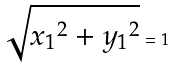Convert formula to latex. <formula><loc_0><loc_0><loc_500><loc_500>\sqrt { { x _ { 1 } } ^ { 2 } + { y _ { 1 } } ^ { 2 } } = 1</formula> 